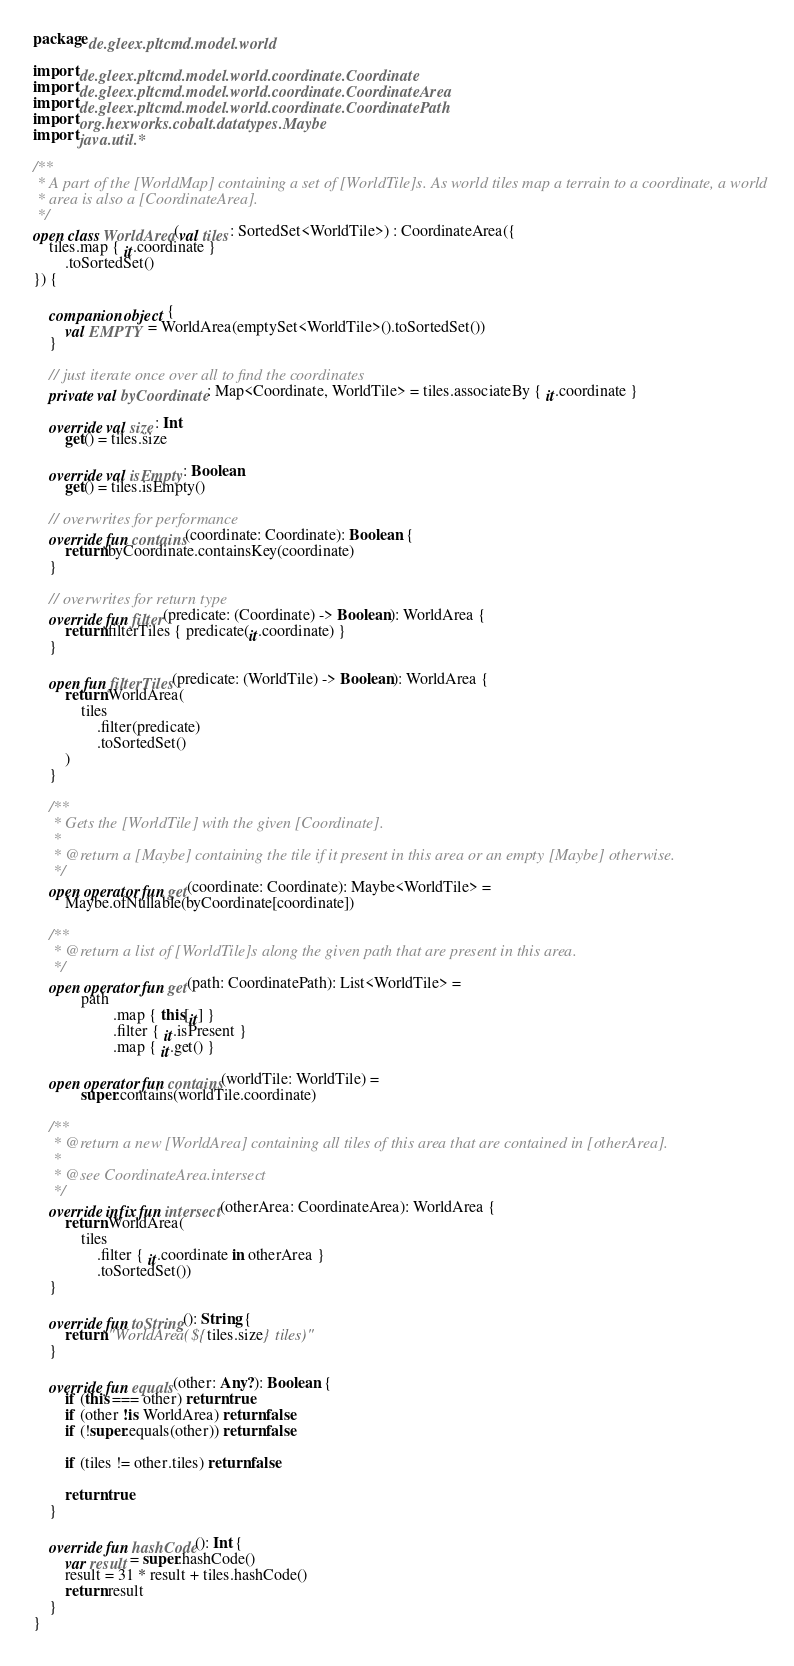<code> <loc_0><loc_0><loc_500><loc_500><_Kotlin_>package de.gleex.pltcmd.model.world

import de.gleex.pltcmd.model.world.coordinate.Coordinate
import de.gleex.pltcmd.model.world.coordinate.CoordinateArea
import de.gleex.pltcmd.model.world.coordinate.CoordinatePath
import org.hexworks.cobalt.datatypes.Maybe
import java.util.*

/**
 * A part of the [WorldMap] containing a set of [WorldTile]s. As world tiles map a terrain to a coordinate, a world
 * area is also a [CoordinateArea].
 */
open class WorldArea(val tiles: SortedSet<WorldTile>) : CoordinateArea({
    tiles.map { it.coordinate }
        .toSortedSet()
}) {

    companion object {
        val EMPTY = WorldArea(emptySet<WorldTile>().toSortedSet())
    }

    // just iterate once over all to find the coordinates
    private val byCoordinate: Map<Coordinate, WorldTile> = tiles.associateBy { it.coordinate }

    override val size: Int
        get() = tiles.size

    override val isEmpty: Boolean
        get() = tiles.isEmpty()

    // overwrites for performance
    override fun contains(coordinate: Coordinate): Boolean {
        return byCoordinate.containsKey(coordinate)
    }

    // overwrites for return type
    override fun filter(predicate: (Coordinate) -> Boolean): WorldArea {
        return filterTiles { predicate(it.coordinate) }
    }

    open fun filterTiles(predicate: (WorldTile) -> Boolean): WorldArea {
        return WorldArea(
            tiles
                .filter(predicate)
                .toSortedSet()
        )
    }

    /**
     * Gets the [WorldTile] with the given [Coordinate].
     *
     * @return a [Maybe] containing the tile if it present in this area or an empty [Maybe] otherwise.
     */
    open operator fun get(coordinate: Coordinate): Maybe<WorldTile> =
        Maybe.ofNullable(byCoordinate[coordinate])

    /**
     * @return a list of [WorldTile]s along the given path that are present in this area.
     */
    open operator fun get(path: CoordinatePath): List<WorldTile> =
            path
                    .map { this[it] }
                    .filter { it.isPresent }
                    .map { it.get() }

    open operator fun contains(worldTile: WorldTile) =
            super.contains(worldTile.coordinate)

    /**
     * @return a new [WorldArea] containing all tiles of this area that are contained in [otherArea].
     *
     * @see CoordinateArea.intersect
     */
    override infix fun intersect(otherArea: CoordinateArea): WorldArea {
        return WorldArea(
            tiles
                .filter { it.coordinate in otherArea }
                .toSortedSet())
    }

    override fun toString(): String {
        return "WorldArea(${tiles.size} tiles)"
    }

    override fun equals(other: Any?): Boolean {
        if (this === other) return true
        if (other !is WorldArea) return false
        if (!super.equals(other)) return false

        if (tiles != other.tiles) return false

        return true
    }

    override fun hashCode(): Int {
        var result = super.hashCode()
        result = 31 * result + tiles.hashCode()
        return result
    }
}
</code> 